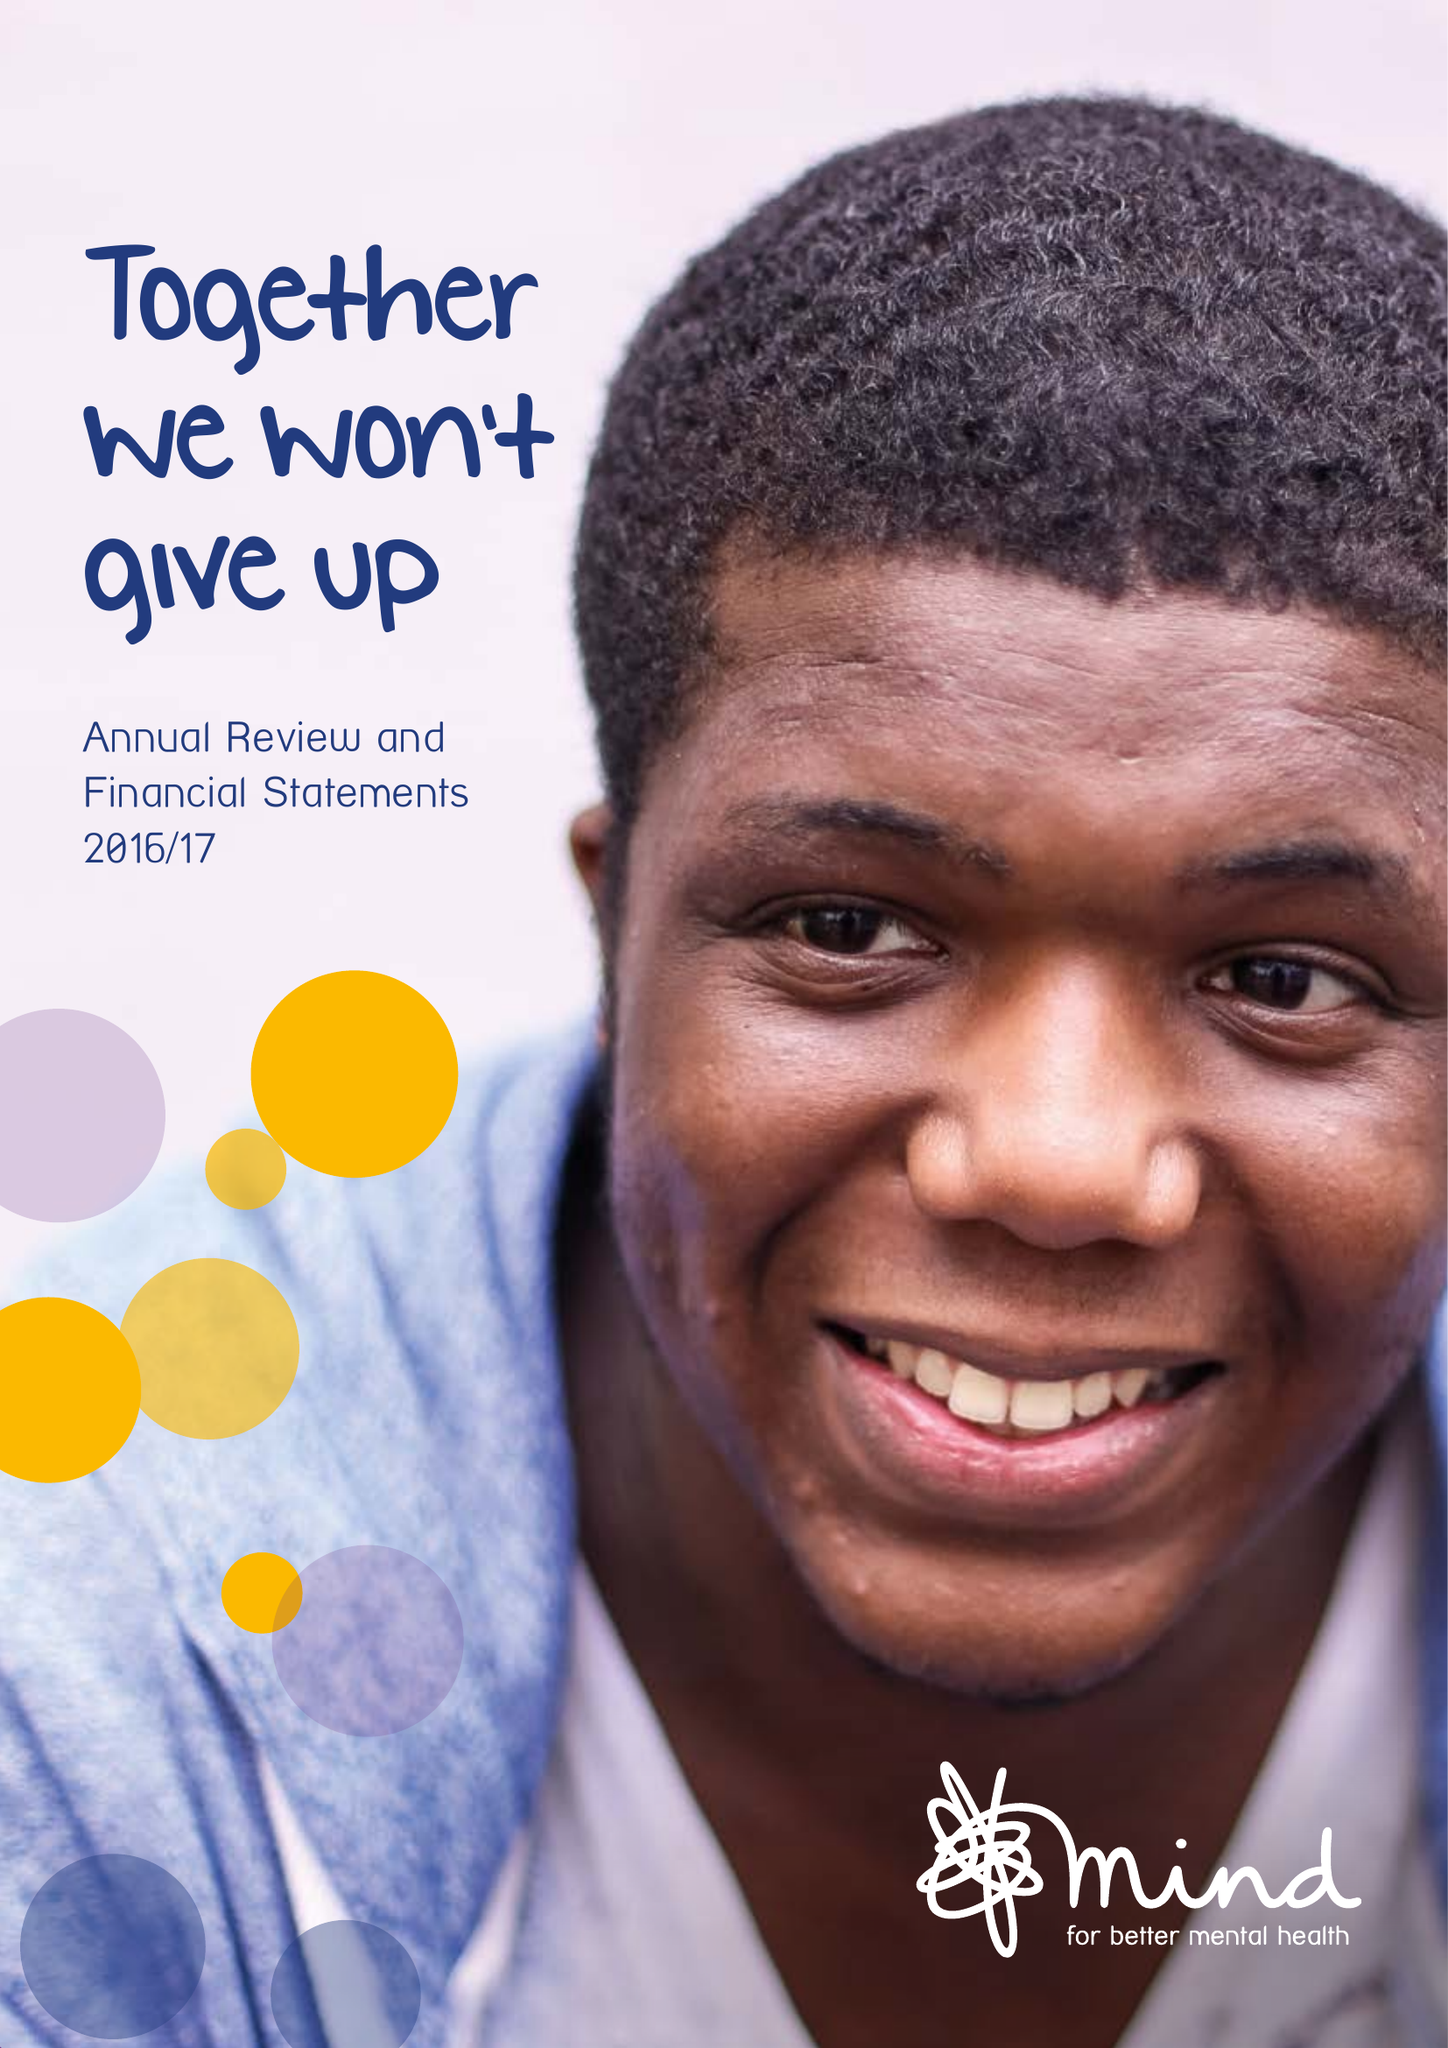What is the value for the report_date?
Answer the question using a single word or phrase. 2017-03-31 